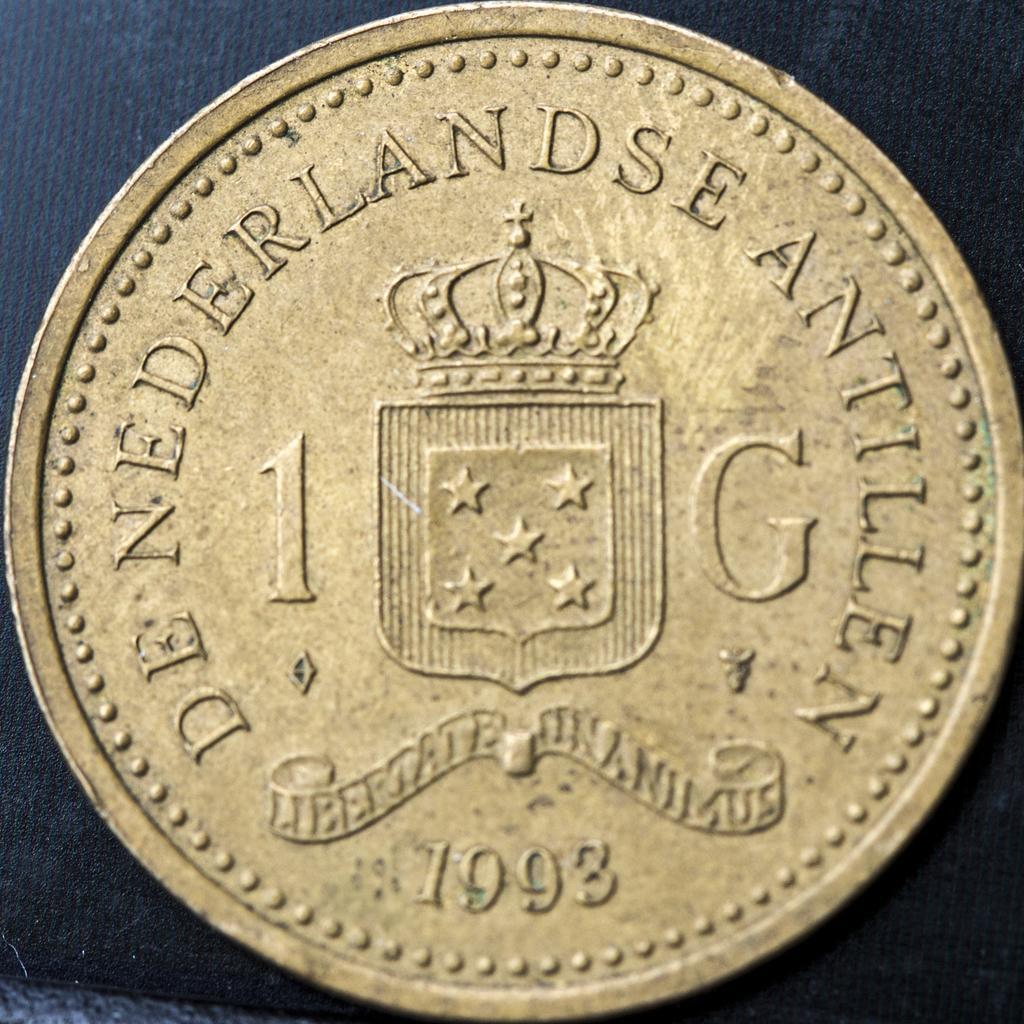<image>
Give a short and clear explanation of the subsequent image. Coin valued at 1 G from 1993 with a crown and crest with 5 stars from the Netherlands 